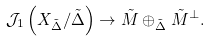<formula> <loc_0><loc_0><loc_500><loc_500>\mathcal { J } _ { 1 } \left ( X _ { \tilde { \Delta } } / \tilde { \Delta } \right ) \rightarrow \tilde { M } \oplus _ { \tilde { \Delta } } \tilde { M } ^ { \bot } .</formula> 